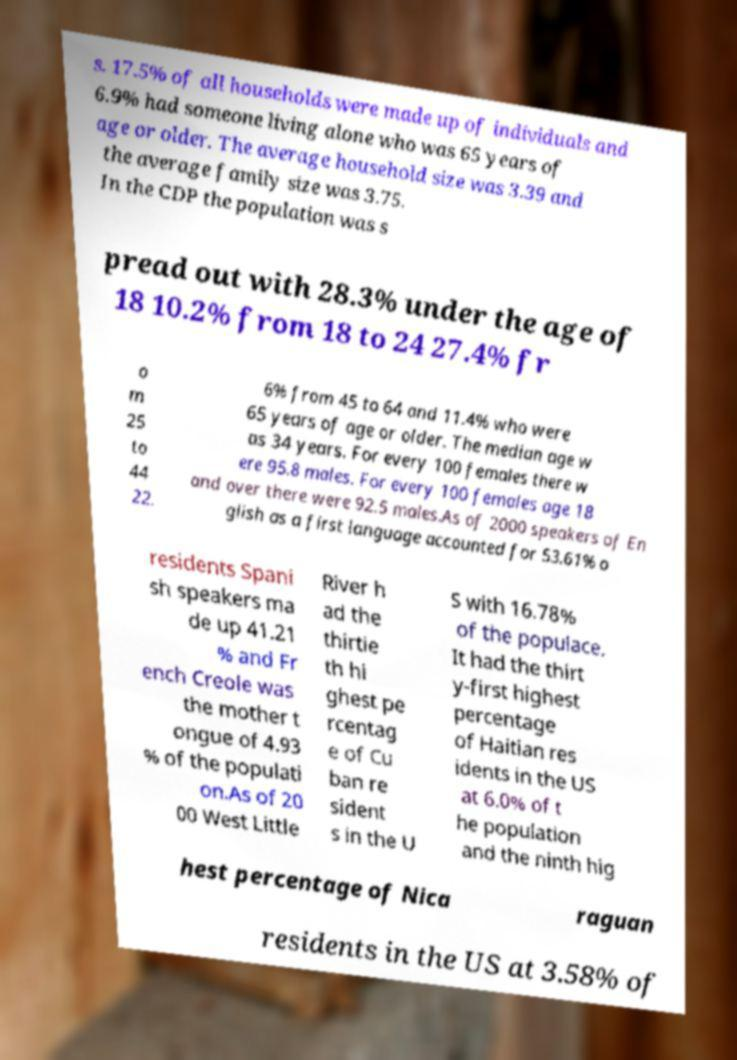Can you accurately transcribe the text from the provided image for me? s. 17.5% of all households were made up of individuals and 6.9% had someone living alone who was 65 years of age or older. The average household size was 3.39 and the average family size was 3.75. In the CDP the population was s pread out with 28.3% under the age of 18 10.2% from 18 to 24 27.4% fr o m 25 to 44 22. 6% from 45 to 64 and 11.4% who were 65 years of age or older. The median age w as 34 years. For every 100 females there w ere 95.8 males. For every 100 females age 18 and over there were 92.5 males.As of 2000 speakers of En glish as a first language accounted for 53.61% o residents Spani sh speakers ma de up 41.21 % and Fr ench Creole was the mother t ongue of 4.93 % of the populati on.As of 20 00 West Little River h ad the thirtie th hi ghest pe rcentag e of Cu ban re sident s in the U S with 16.78% of the populace. It had the thirt y-first highest percentage of Haitian res idents in the US at 6.0% of t he population and the ninth hig hest percentage of Nica raguan residents in the US at 3.58% of 